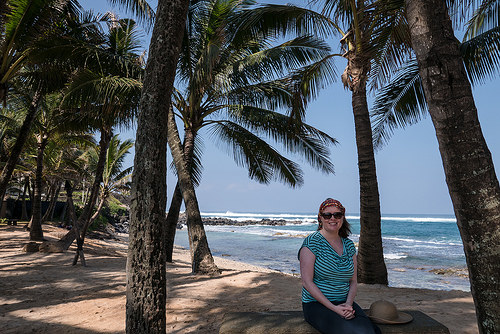<image>
Is there a tree in front of the ocean? Yes. The tree is positioned in front of the ocean, appearing closer to the camera viewpoint. 